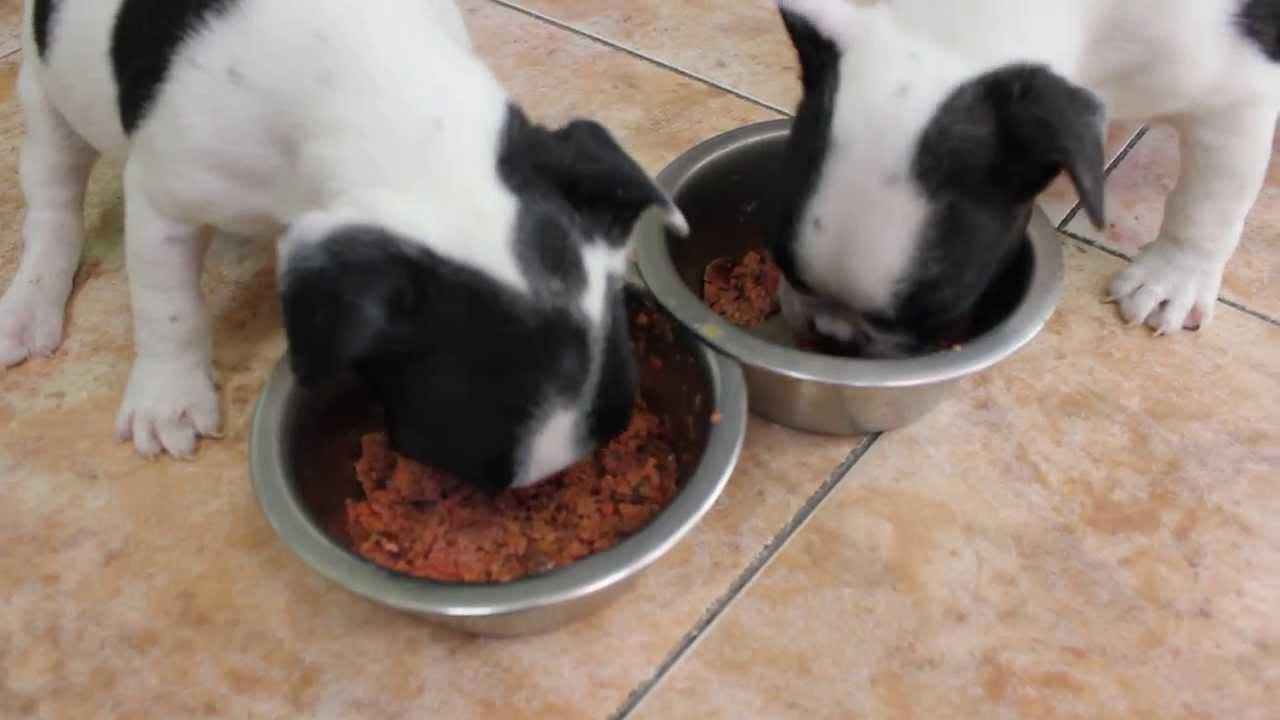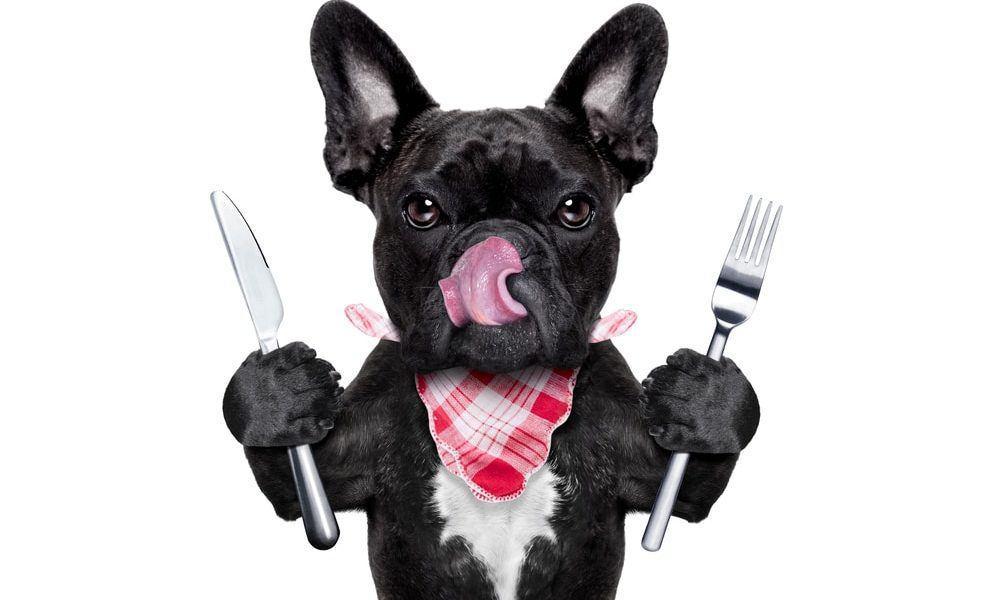The first image is the image on the left, the second image is the image on the right. Analyze the images presented: Is the assertion "One image in the pair shows at least one dog eating." valid? Answer yes or no. Yes. The first image is the image on the left, the second image is the image on the right. Evaluate the accuracy of this statement regarding the images: "One image features a french bulldog wearing a checkered napkin around its neck, and the other image includes a silver-colored dog food bowl and at least one bulldog.". Is it true? Answer yes or no. Yes. 